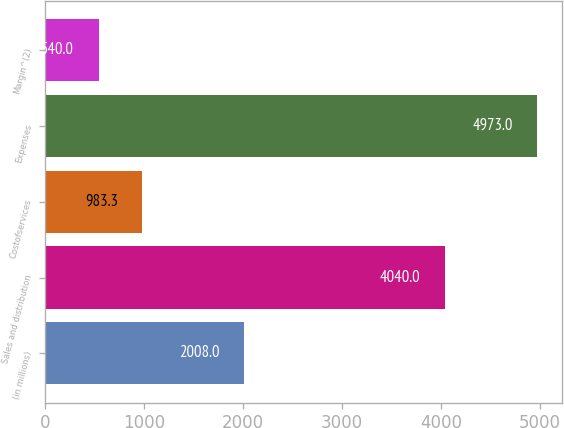Convert chart. <chart><loc_0><loc_0><loc_500><loc_500><bar_chart><fcel>(in millions)<fcel>Sales and distribution<fcel>Costofservices<fcel>Expenses<fcel>Margin^(2)<nl><fcel>2008<fcel>4040<fcel>983.3<fcel>4973<fcel>540<nl></chart> 